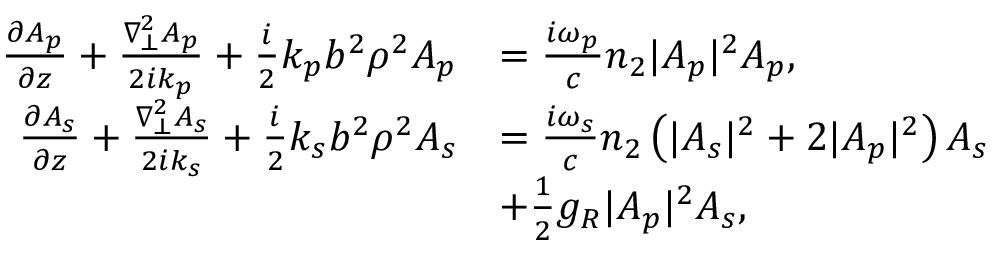<formula> <loc_0><loc_0><loc_500><loc_500>\begin{array} { r l } { \frac { \partial A _ { p } } { \partial z } + \frac { \nabla _ { \bot } ^ { 2 } A _ { p } } { 2 i k _ { p } } + \frac { i } { 2 } k _ { p } b ^ { 2 } \rho ^ { 2 } A _ { p } } & { = \frac { i \omega _ { p } } { c } n _ { 2 } | A _ { p } | ^ { 2 } A _ { p } , } \\ { \frac { \partial A _ { s } } { \partial z } + \frac { \nabla _ { \bot } ^ { 2 } A _ { s } } { 2 i k _ { s } } + \frac { i } { 2 } k _ { s } b ^ { 2 } \rho ^ { 2 } A _ { s } } & { = \frac { i \omega _ { s } } { c } n _ { 2 } \left ( | A _ { s } | ^ { 2 } + 2 | A _ { p } | ^ { 2 } \right ) A _ { s } } \\ & { + \frac { 1 } { 2 } g _ { R } | A _ { p } | ^ { 2 } A _ { s } , } \end{array}</formula> 